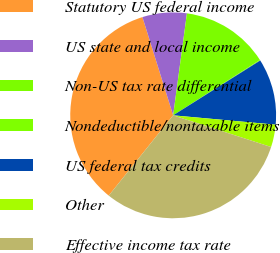<chart> <loc_0><loc_0><loc_500><loc_500><pie_chart><fcel>Statutory US federal income<fcel>US state and local income<fcel>Non-US tax rate differential<fcel>Nondeductible/nontaxable items<fcel>US federal tax credits<fcel>Other<fcel>Effective income tax rate<nl><fcel>34.41%<fcel>6.96%<fcel>13.82%<fcel>0.1%<fcel>10.39%<fcel>3.53%<fcel>30.78%<nl></chart> 